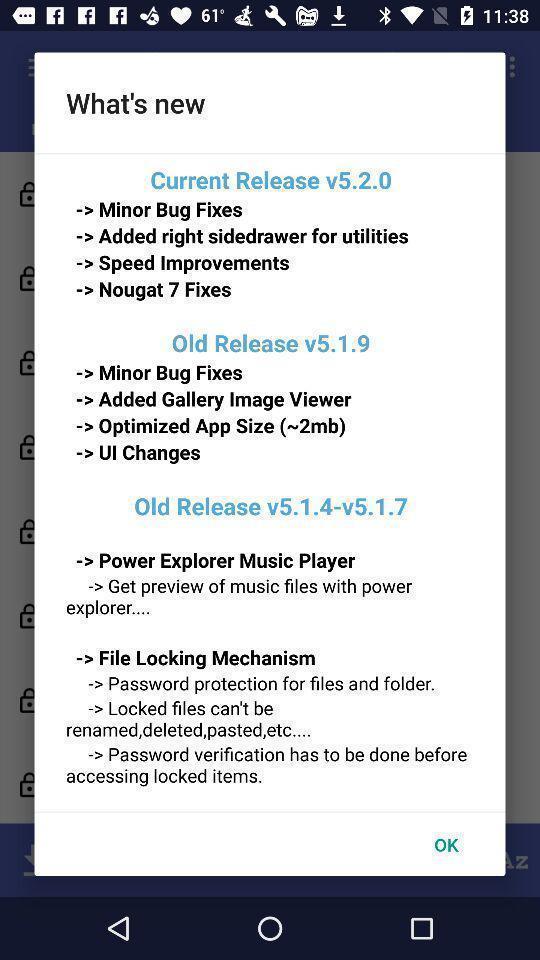Give me a summary of this screen capture. Pop-up showing about the version details. 